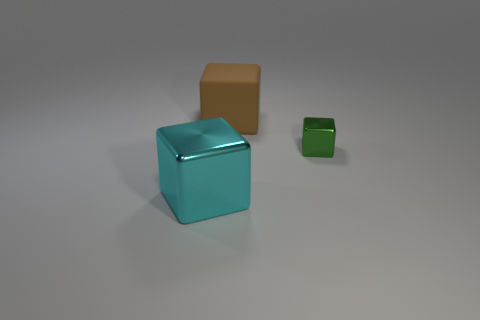Subtract all cyan cubes. How many cubes are left? 2 Subtract all cyan cubes. How many cubes are left? 2 Subtract 1 green cubes. How many objects are left? 2 Subtract all purple cubes. Subtract all gray spheres. How many cubes are left? 3 Subtract all red spheres. How many yellow cubes are left? 0 Subtract all small cyan metallic blocks. Subtract all brown rubber objects. How many objects are left? 2 Add 2 tiny cubes. How many tiny cubes are left? 3 Add 1 tiny red blocks. How many tiny red blocks exist? 1 Add 3 gray metallic spheres. How many objects exist? 6 